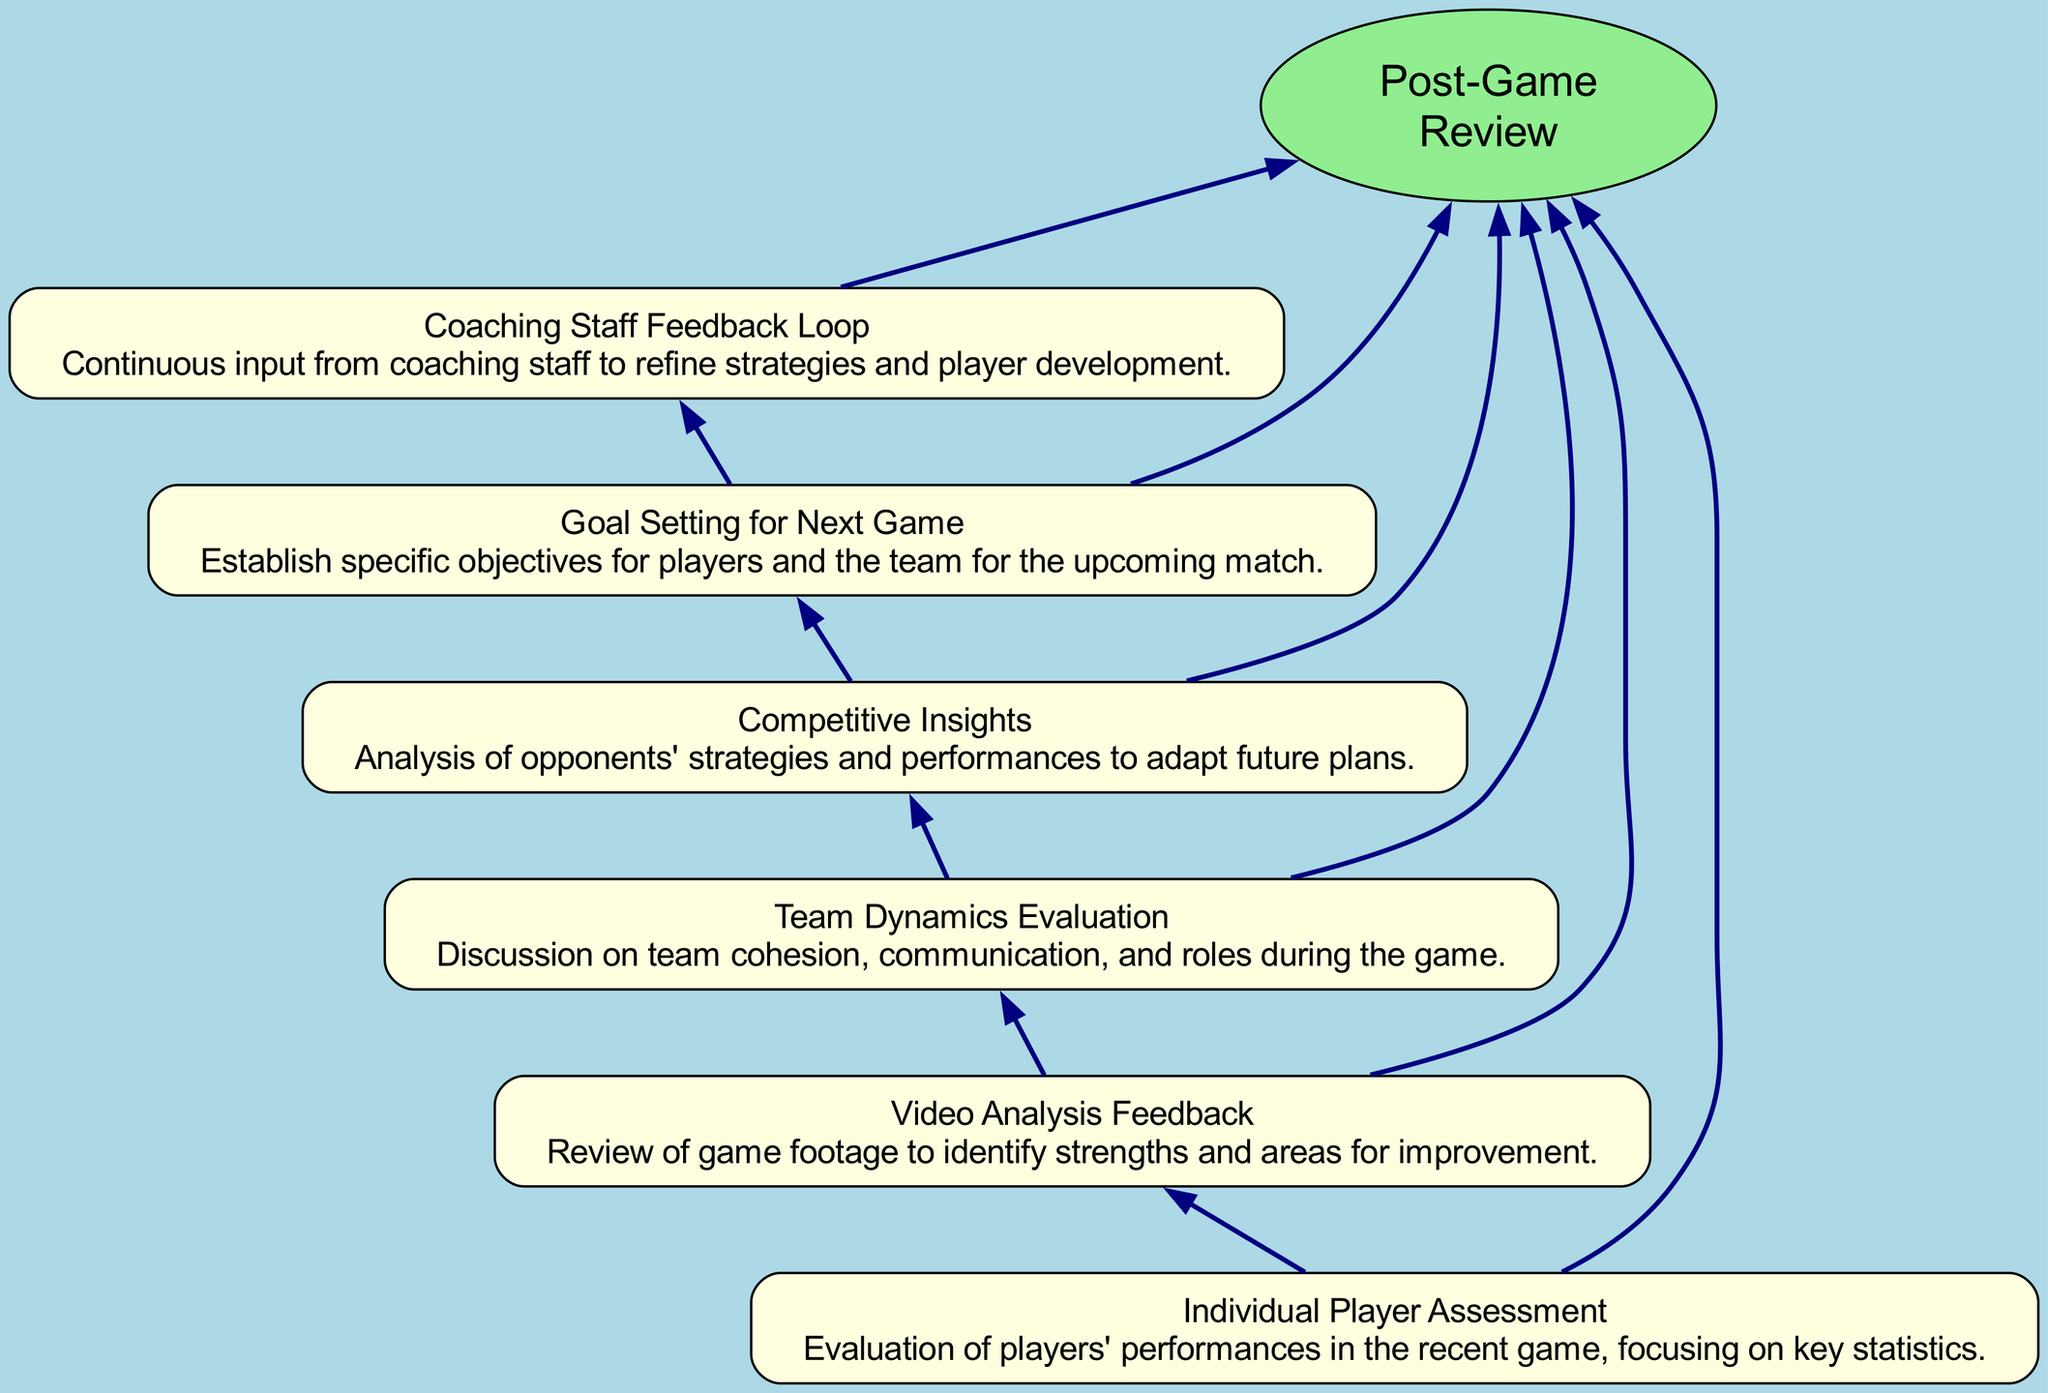What's the main focus of the diagram? The central node labeled "Post-Game Review" indicates the overarching theme of the flow chart, which is to analyze and reflect on the game's outcome.
Answer: Post-Game Review How many elements are evaluated in the diagram? By counting the individual nodes connected to the central node, we see there are six distinct elements related to player performances and team dynamics.
Answer: Six What follows after "Individual Player Assessment" in the flow sequence? The diagram indicates a direct connection from "Individual Player Assessment" to "Video Analysis Feedback," showing the next step in the process after assessing player performances.
Answer: Video Analysis Feedback Which element evaluates team communication? "Team Dynamics Evaluation" is the node that specifically addresses aspects like team cohesion and communication during the game, thus focusing on team interactions.
Answer: Team Dynamics Evaluation How does coaching staff contribute to the review process? "Coaching Staff Feedback Loop" connects back to various elements, emphasizing a continuous input system that refines strategies and player development based on player assessments and dynamics.
Answer: Continuous input What type of insights does the "Competitive Insights" node provide? This node delivers information on opponents' strategies that can be utilized to adapt and improve future game plans, indicating its role in strategic adjustments.
Answer: Opponents' strategies Which process is iterative in nature based on the diagram? The "Coaching Staff Feedback Loop" suggests an iterative process where coaching input continuously affects player development and strategy refinement based on prior evaluations.
Answer: Coaching Staff Feedback Loop What is the final step indicated in the flow chart? The final step, or ultimate goal of the review process, is encapsulated in the "Goal Setting for Next Game" node, establishing objectives grounded on the insights gathered from earlier assessments.
Answer: Goal Setting for Next Game How does "Video Analysis Feedback" interact with the "Individual Player Assessment"? "Video Analysis Feedback" follows directly after "Individual Player Assessment," suggesting that insights obtained from player evaluations are directly analyzed through video footage to identify improvement areas.
Answer: Directly follows 